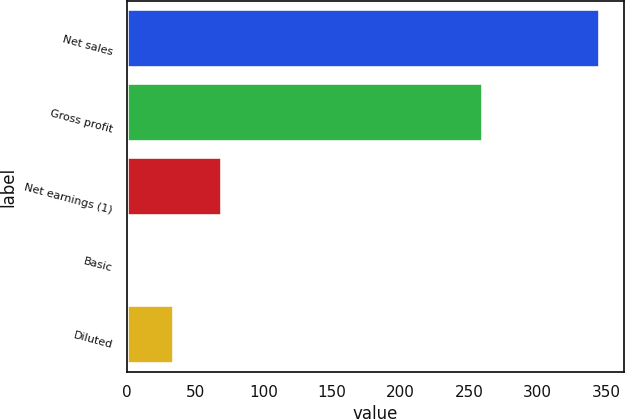Convert chart. <chart><loc_0><loc_0><loc_500><loc_500><bar_chart><fcel>Net sales<fcel>Gross profit<fcel>Net earnings (1)<fcel>Basic<fcel>Diluted<nl><fcel>345.6<fcel>260.4<fcel>69.4<fcel>0.34<fcel>34.87<nl></chart> 